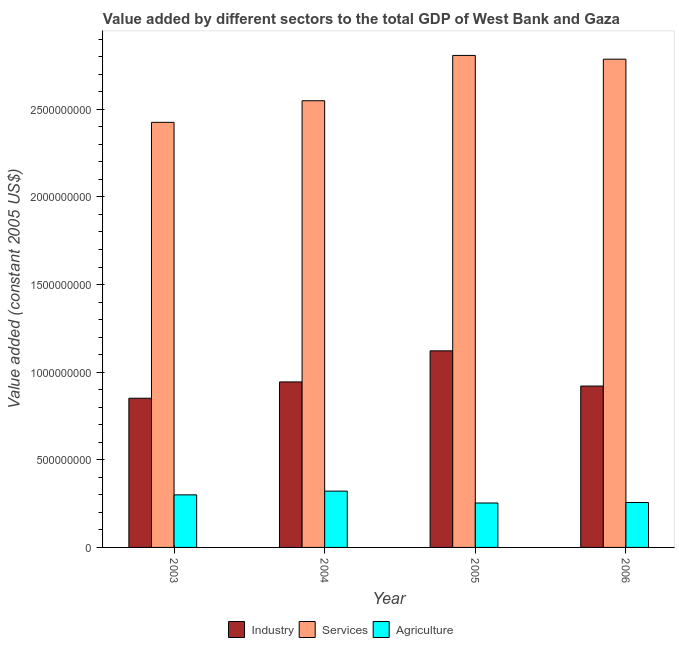How many groups of bars are there?
Offer a terse response. 4. How many bars are there on the 1st tick from the left?
Give a very brief answer. 3. What is the label of the 3rd group of bars from the left?
Give a very brief answer. 2005. What is the value added by services in 2004?
Offer a very short reply. 2.55e+09. Across all years, what is the maximum value added by industrial sector?
Offer a very short reply. 1.12e+09. Across all years, what is the minimum value added by services?
Offer a terse response. 2.43e+09. What is the total value added by industrial sector in the graph?
Your answer should be very brief. 3.84e+09. What is the difference between the value added by industrial sector in 2004 and that in 2005?
Your answer should be very brief. -1.77e+08. What is the difference between the value added by services in 2003 and the value added by agricultural sector in 2005?
Provide a short and direct response. -3.82e+08. What is the average value added by agricultural sector per year?
Ensure brevity in your answer.  2.83e+08. In the year 2006, what is the difference between the value added by industrial sector and value added by services?
Your response must be concise. 0. In how many years, is the value added by industrial sector greater than 2400000000 US$?
Give a very brief answer. 0. What is the ratio of the value added by services in 2005 to that in 2006?
Ensure brevity in your answer.  1.01. Is the value added by agricultural sector in 2003 less than that in 2004?
Your answer should be compact. Yes. What is the difference between the highest and the second highest value added by industrial sector?
Keep it short and to the point. 1.77e+08. What is the difference between the highest and the lowest value added by industrial sector?
Keep it short and to the point. 2.70e+08. In how many years, is the value added by services greater than the average value added by services taken over all years?
Keep it short and to the point. 2. Is the sum of the value added by services in 2003 and 2004 greater than the maximum value added by agricultural sector across all years?
Keep it short and to the point. Yes. What does the 1st bar from the left in 2003 represents?
Ensure brevity in your answer.  Industry. What does the 3rd bar from the right in 2004 represents?
Offer a very short reply. Industry. How many years are there in the graph?
Make the answer very short. 4. Are the values on the major ticks of Y-axis written in scientific E-notation?
Provide a short and direct response. No. Does the graph contain grids?
Offer a terse response. No. Where does the legend appear in the graph?
Make the answer very short. Bottom center. How many legend labels are there?
Keep it short and to the point. 3. What is the title of the graph?
Your answer should be compact. Value added by different sectors to the total GDP of West Bank and Gaza. Does "Renewable sources" appear as one of the legend labels in the graph?
Your response must be concise. No. What is the label or title of the X-axis?
Keep it short and to the point. Year. What is the label or title of the Y-axis?
Offer a very short reply. Value added (constant 2005 US$). What is the Value added (constant 2005 US$) in Industry in 2003?
Make the answer very short. 8.51e+08. What is the Value added (constant 2005 US$) in Services in 2003?
Your response must be concise. 2.43e+09. What is the Value added (constant 2005 US$) in Agriculture in 2003?
Give a very brief answer. 3.00e+08. What is the Value added (constant 2005 US$) of Industry in 2004?
Your answer should be compact. 9.44e+08. What is the Value added (constant 2005 US$) of Services in 2004?
Keep it short and to the point. 2.55e+09. What is the Value added (constant 2005 US$) in Agriculture in 2004?
Your answer should be very brief. 3.21e+08. What is the Value added (constant 2005 US$) in Industry in 2005?
Ensure brevity in your answer.  1.12e+09. What is the Value added (constant 2005 US$) of Services in 2005?
Offer a terse response. 2.81e+09. What is the Value added (constant 2005 US$) in Agriculture in 2005?
Provide a succinct answer. 2.53e+08. What is the Value added (constant 2005 US$) of Industry in 2006?
Your response must be concise. 9.21e+08. What is the Value added (constant 2005 US$) of Services in 2006?
Offer a terse response. 2.79e+09. What is the Value added (constant 2005 US$) in Agriculture in 2006?
Keep it short and to the point. 2.56e+08. Across all years, what is the maximum Value added (constant 2005 US$) of Industry?
Your response must be concise. 1.12e+09. Across all years, what is the maximum Value added (constant 2005 US$) of Services?
Offer a terse response. 2.81e+09. Across all years, what is the maximum Value added (constant 2005 US$) of Agriculture?
Offer a terse response. 3.21e+08. Across all years, what is the minimum Value added (constant 2005 US$) in Industry?
Keep it short and to the point. 8.51e+08. Across all years, what is the minimum Value added (constant 2005 US$) of Services?
Your answer should be compact. 2.43e+09. Across all years, what is the minimum Value added (constant 2005 US$) of Agriculture?
Your response must be concise. 2.53e+08. What is the total Value added (constant 2005 US$) in Industry in the graph?
Offer a very short reply. 3.84e+09. What is the total Value added (constant 2005 US$) of Services in the graph?
Ensure brevity in your answer.  1.06e+1. What is the total Value added (constant 2005 US$) in Agriculture in the graph?
Make the answer very short. 1.13e+09. What is the difference between the Value added (constant 2005 US$) of Industry in 2003 and that in 2004?
Offer a very short reply. -9.30e+07. What is the difference between the Value added (constant 2005 US$) in Services in 2003 and that in 2004?
Provide a succinct answer. -1.23e+08. What is the difference between the Value added (constant 2005 US$) in Agriculture in 2003 and that in 2004?
Give a very brief answer. -2.14e+07. What is the difference between the Value added (constant 2005 US$) in Industry in 2003 and that in 2005?
Ensure brevity in your answer.  -2.70e+08. What is the difference between the Value added (constant 2005 US$) in Services in 2003 and that in 2005?
Provide a succinct answer. -3.82e+08. What is the difference between the Value added (constant 2005 US$) in Agriculture in 2003 and that in 2005?
Offer a very short reply. 4.65e+07. What is the difference between the Value added (constant 2005 US$) of Industry in 2003 and that in 2006?
Offer a very short reply. -6.95e+07. What is the difference between the Value added (constant 2005 US$) in Services in 2003 and that in 2006?
Your answer should be compact. -3.60e+08. What is the difference between the Value added (constant 2005 US$) in Agriculture in 2003 and that in 2006?
Your answer should be very brief. 4.36e+07. What is the difference between the Value added (constant 2005 US$) in Industry in 2004 and that in 2005?
Give a very brief answer. -1.77e+08. What is the difference between the Value added (constant 2005 US$) in Services in 2004 and that in 2005?
Provide a short and direct response. -2.59e+08. What is the difference between the Value added (constant 2005 US$) in Agriculture in 2004 and that in 2005?
Offer a very short reply. 6.79e+07. What is the difference between the Value added (constant 2005 US$) of Industry in 2004 and that in 2006?
Offer a very short reply. 2.35e+07. What is the difference between the Value added (constant 2005 US$) of Services in 2004 and that in 2006?
Provide a succinct answer. -2.37e+08. What is the difference between the Value added (constant 2005 US$) of Agriculture in 2004 and that in 2006?
Ensure brevity in your answer.  6.50e+07. What is the difference between the Value added (constant 2005 US$) in Industry in 2005 and that in 2006?
Provide a succinct answer. 2.01e+08. What is the difference between the Value added (constant 2005 US$) in Services in 2005 and that in 2006?
Your answer should be very brief. 2.14e+07. What is the difference between the Value added (constant 2005 US$) of Agriculture in 2005 and that in 2006?
Your answer should be very brief. -2.89e+06. What is the difference between the Value added (constant 2005 US$) in Industry in 2003 and the Value added (constant 2005 US$) in Services in 2004?
Provide a short and direct response. -1.70e+09. What is the difference between the Value added (constant 2005 US$) of Industry in 2003 and the Value added (constant 2005 US$) of Agriculture in 2004?
Provide a short and direct response. 5.30e+08. What is the difference between the Value added (constant 2005 US$) in Services in 2003 and the Value added (constant 2005 US$) in Agriculture in 2004?
Your response must be concise. 2.10e+09. What is the difference between the Value added (constant 2005 US$) of Industry in 2003 and the Value added (constant 2005 US$) of Services in 2005?
Your response must be concise. -1.96e+09. What is the difference between the Value added (constant 2005 US$) in Industry in 2003 and the Value added (constant 2005 US$) in Agriculture in 2005?
Provide a short and direct response. 5.98e+08. What is the difference between the Value added (constant 2005 US$) in Services in 2003 and the Value added (constant 2005 US$) in Agriculture in 2005?
Make the answer very short. 2.17e+09. What is the difference between the Value added (constant 2005 US$) of Industry in 2003 and the Value added (constant 2005 US$) of Services in 2006?
Make the answer very short. -1.93e+09. What is the difference between the Value added (constant 2005 US$) in Industry in 2003 and the Value added (constant 2005 US$) in Agriculture in 2006?
Your answer should be very brief. 5.95e+08. What is the difference between the Value added (constant 2005 US$) of Services in 2003 and the Value added (constant 2005 US$) of Agriculture in 2006?
Ensure brevity in your answer.  2.17e+09. What is the difference between the Value added (constant 2005 US$) of Industry in 2004 and the Value added (constant 2005 US$) of Services in 2005?
Provide a succinct answer. -1.86e+09. What is the difference between the Value added (constant 2005 US$) in Industry in 2004 and the Value added (constant 2005 US$) in Agriculture in 2005?
Offer a very short reply. 6.91e+08. What is the difference between the Value added (constant 2005 US$) of Services in 2004 and the Value added (constant 2005 US$) of Agriculture in 2005?
Your answer should be compact. 2.30e+09. What is the difference between the Value added (constant 2005 US$) of Industry in 2004 and the Value added (constant 2005 US$) of Services in 2006?
Provide a succinct answer. -1.84e+09. What is the difference between the Value added (constant 2005 US$) in Industry in 2004 and the Value added (constant 2005 US$) in Agriculture in 2006?
Your answer should be very brief. 6.88e+08. What is the difference between the Value added (constant 2005 US$) in Services in 2004 and the Value added (constant 2005 US$) in Agriculture in 2006?
Your response must be concise. 2.29e+09. What is the difference between the Value added (constant 2005 US$) in Industry in 2005 and the Value added (constant 2005 US$) in Services in 2006?
Keep it short and to the point. -1.66e+09. What is the difference between the Value added (constant 2005 US$) in Industry in 2005 and the Value added (constant 2005 US$) in Agriculture in 2006?
Your response must be concise. 8.65e+08. What is the difference between the Value added (constant 2005 US$) in Services in 2005 and the Value added (constant 2005 US$) in Agriculture in 2006?
Provide a succinct answer. 2.55e+09. What is the average Value added (constant 2005 US$) of Industry per year?
Ensure brevity in your answer.  9.60e+08. What is the average Value added (constant 2005 US$) of Services per year?
Offer a very short reply. 2.64e+09. What is the average Value added (constant 2005 US$) of Agriculture per year?
Your answer should be compact. 2.83e+08. In the year 2003, what is the difference between the Value added (constant 2005 US$) of Industry and Value added (constant 2005 US$) of Services?
Offer a terse response. -1.57e+09. In the year 2003, what is the difference between the Value added (constant 2005 US$) of Industry and Value added (constant 2005 US$) of Agriculture?
Give a very brief answer. 5.51e+08. In the year 2003, what is the difference between the Value added (constant 2005 US$) of Services and Value added (constant 2005 US$) of Agriculture?
Give a very brief answer. 2.13e+09. In the year 2004, what is the difference between the Value added (constant 2005 US$) in Industry and Value added (constant 2005 US$) in Services?
Provide a succinct answer. -1.60e+09. In the year 2004, what is the difference between the Value added (constant 2005 US$) of Industry and Value added (constant 2005 US$) of Agriculture?
Ensure brevity in your answer.  6.23e+08. In the year 2004, what is the difference between the Value added (constant 2005 US$) of Services and Value added (constant 2005 US$) of Agriculture?
Your answer should be compact. 2.23e+09. In the year 2005, what is the difference between the Value added (constant 2005 US$) of Industry and Value added (constant 2005 US$) of Services?
Give a very brief answer. -1.69e+09. In the year 2005, what is the difference between the Value added (constant 2005 US$) of Industry and Value added (constant 2005 US$) of Agriculture?
Ensure brevity in your answer.  8.68e+08. In the year 2005, what is the difference between the Value added (constant 2005 US$) of Services and Value added (constant 2005 US$) of Agriculture?
Ensure brevity in your answer.  2.55e+09. In the year 2006, what is the difference between the Value added (constant 2005 US$) of Industry and Value added (constant 2005 US$) of Services?
Ensure brevity in your answer.  -1.87e+09. In the year 2006, what is the difference between the Value added (constant 2005 US$) of Industry and Value added (constant 2005 US$) of Agriculture?
Your response must be concise. 6.65e+08. In the year 2006, what is the difference between the Value added (constant 2005 US$) of Services and Value added (constant 2005 US$) of Agriculture?
Give a very brief answer. 2.53e+09. What is the ratio of the Value added (constant 2005 US$) of Industry in 2003 to that in 2004?
Provide a short and direct response. 0.9. What is the ratio of the Value added (constant 2005 US$) in Services in 2003 to that in 2004?
Provide a succinct answer. 0.95. What is the ratio of the Value added (constant 2005 US$) of Industry in 2003 to that in 2005?
Your answer should be very brief. 0.76. What is the ratio of the Value added (constant 2005 US$) in Services in 2003 to that in 2005?
Provide a short and direct response. 0.86. What is the ratio of the Value added (constant 2005 US$) in Agriculture in 2003 to that in 2005?
Offer a terse response. 1.18. What is the ratio of the Value added (constant 2005 US$) in Industry in 2003 to that in 2006?
Provide a succinct answer. 0.92. What is the ratio of the Value added (constant 2005 US$) of Services in 2003 to that in 2006?
Give a very brief answer. 0.87. What is the ratio of the Value added (constant 2005 US$) of Agriculture in 2003 to that in 2006?
Your answer should be compact. 1.17. What is the ratio of the Value added (constant 2005 US$) in Industry in 2004 to that in 2005?
Make the answer very short. 0.84. What is the ratio of the Value added (constant 2005 US$) of Services in 2004 to that in 2005?
Give a very brief answer. 0.91. What is the ratio of the Value added (constant 2005 US$) of Agriculture in 2004 to that in 2005?
Your response must be concise. 1.27. What is the ratio of the Value added (constant 2005 US$) of Industry in 2004 to that in 2006?
Make the answer very short. 1.03. What is the ratio of the Value added (constant 2005 US$) in Services in 2004 to that in 2006?
Your answer should be very brief. 0.91. What is the ratio of the Value added (constant 2005 US$) of Agriculture in 2004 to that in 2006?
Give a very brief answer. 1.25. What is the ratio of the Value added (constant 2005 US$) of Industry in 2005 to that in 2006?
Make the answer very short. 1.22. What is the ratio of the Value added (constant 2005 US$) in Services in 2005 to that in 2006?
Your answer should be compact. 1.01. What is the ratio of the Value added (constant 2005 US$) of Agriculture in 2005 to that in 2006?
Provide a short and direct response. 0.99. What is the difference between the highest and the second highest Value added (constant 2005 US$) of Industry?
Offer a terse response. 1.77e+08. What is the difference between the highest and the second highest Value added (constant 2005 US$) in Services?
Ensure brevity in your answer.  2.14e+07. What is the difference between the highest and the second highest Value added (constant 2005 US$) of Agriculture?
Keep it short and to the point. 2.14e+07. What is the difference between the highest and the lowest Value added (constant 2005 US$) of Industry?
Offer a terse response. 2.70e+08. What is the difference between the highest and the lowest Value added (constant 2005 US$) in Services?
Provide a short and direct response. 3.82e+08. What is the difference between the highest and the lowest Value added (constant 2005 US$) of Agriculture?
Your answer should be compact. 6.79e+07. 